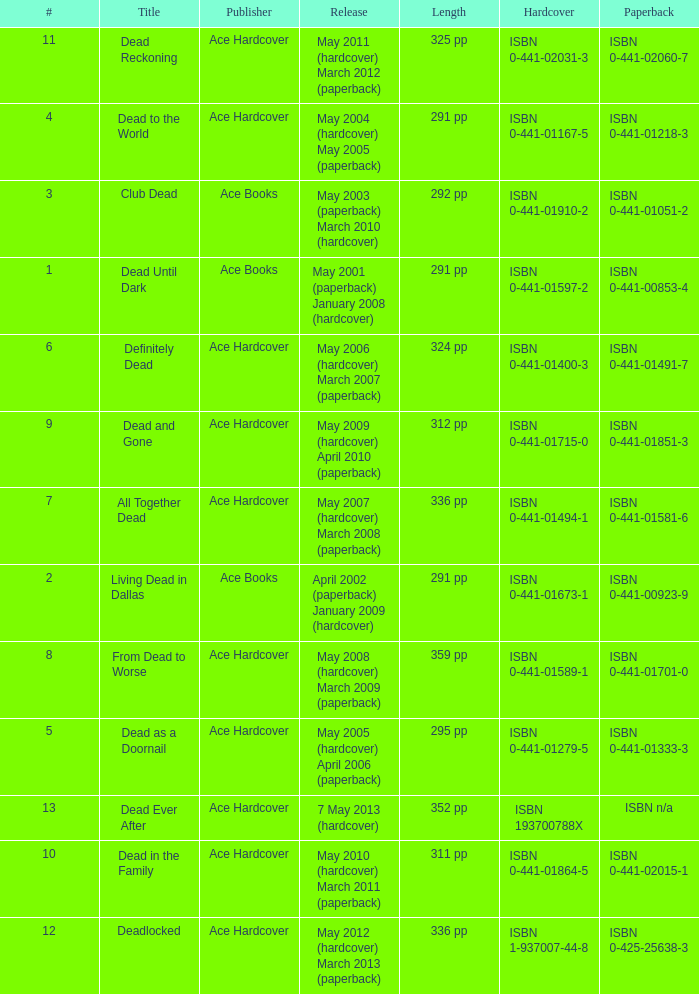Who pubilshed isbn 1-937007-44-8? Ace Hardcover. 